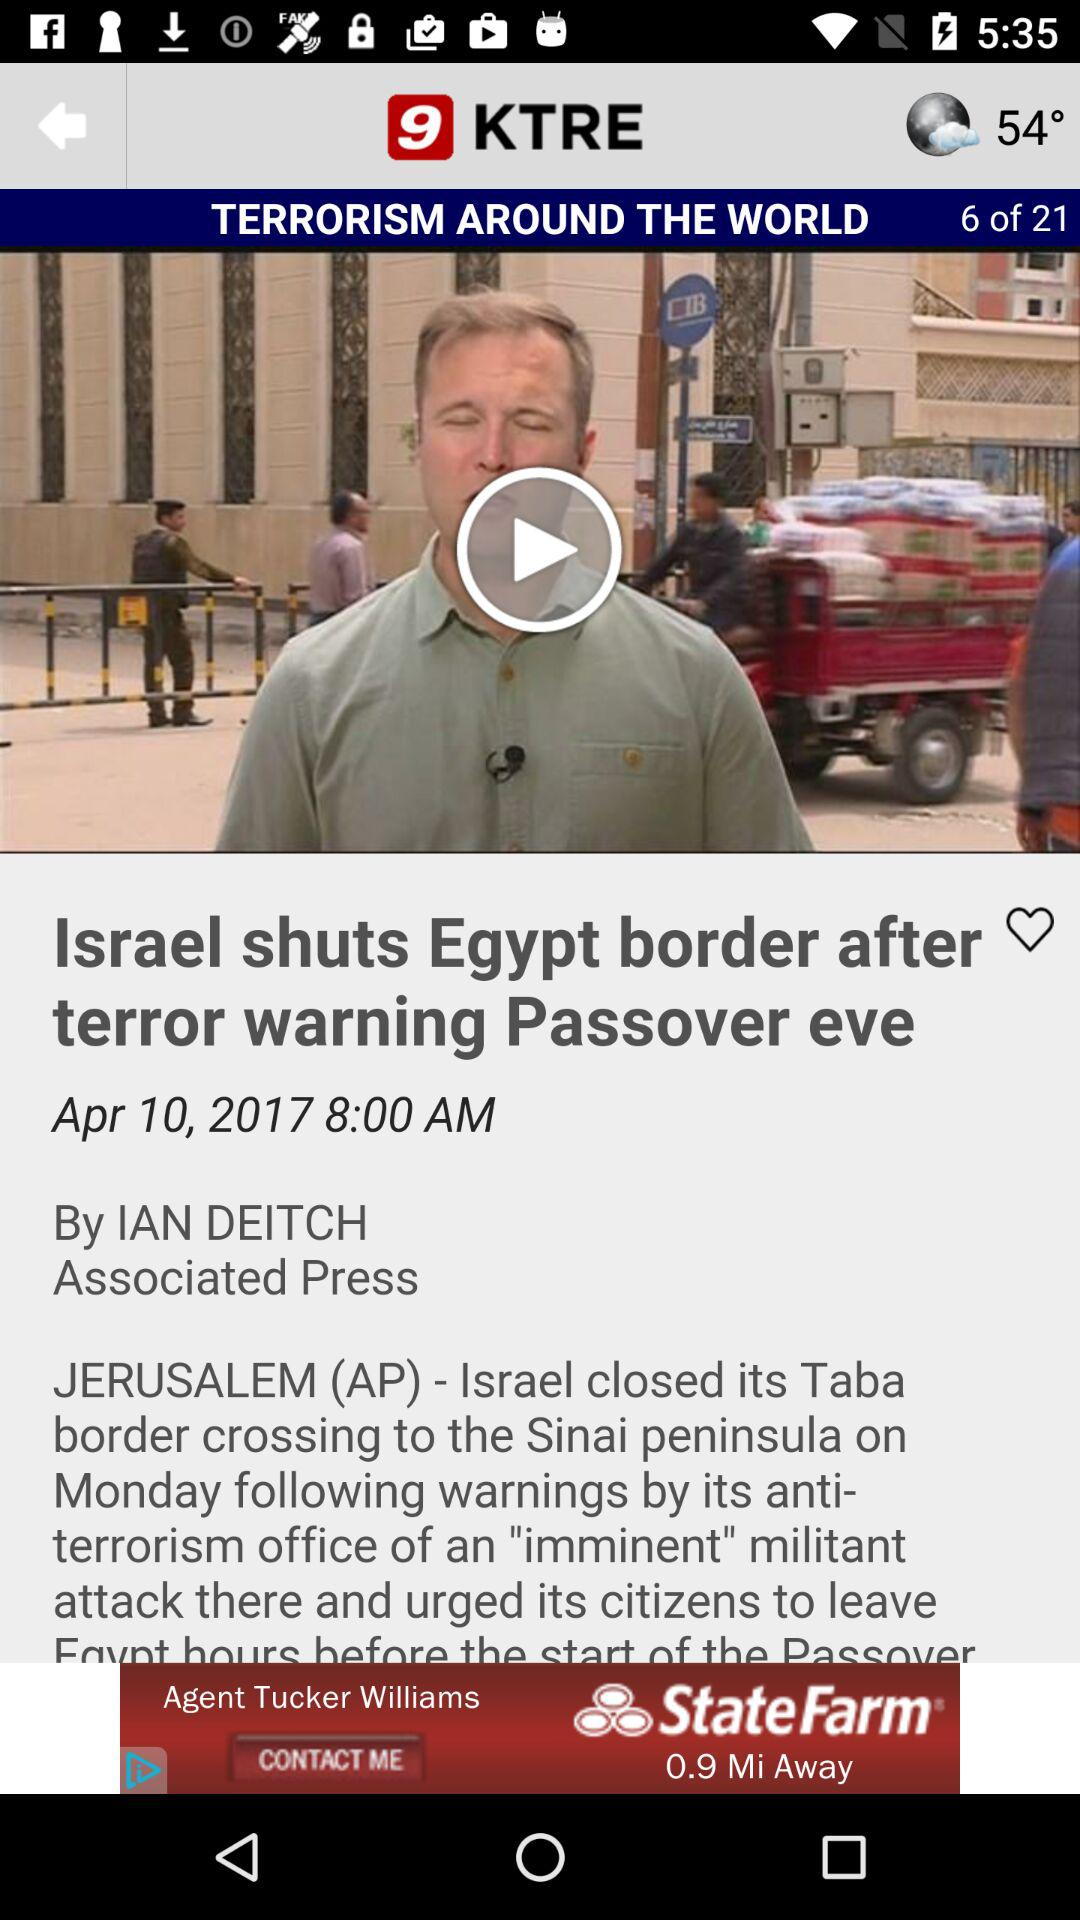What is the posted date? The posted date is April 10, 2017. 